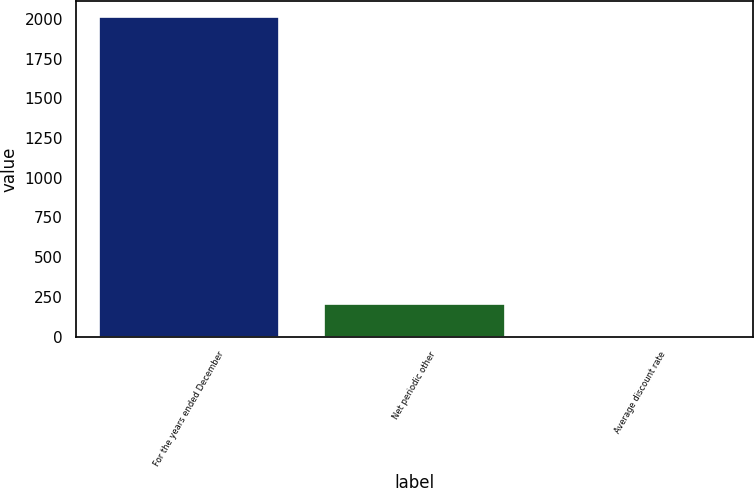Convert chart to OTSL. <chart><loc_0><loc_0><loc_500><loc_500><bar_chart><fcel>For the years ended December<fcel>Net periodic other<fcel>Average discount rate<nl><fcel>2011<fcel>205.78<fcel>5.2<nl></chart> 